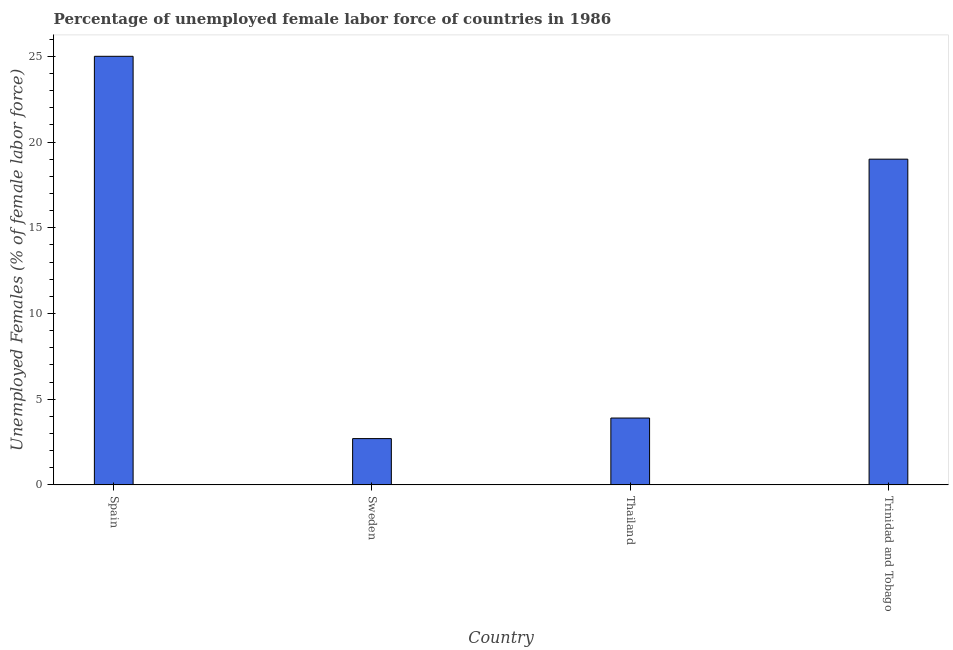What is the title of the graph?
Keep it short and to the point. Percentage of unemployed female labor force of countries in 1986. What is the label or title of the Y-axis?
Provide a succinct answer. Unemployed Females (% of female labor force). What is the total unemployed female labour force in Sweden?
Your answer should be compact. 2.7. Across all countries, what is the maximum total unemployed female labour force?
Give a very brief answer. 25. Across all countries, what is the minimum total unemployed female labour force?
Keep it short and to the point. 2.7. What is the sum of the total unemployed female labour force?
Your answer should be compact. 50.6. What is the difference between the total unemployed female labour force in Spain and Sweden?
Provide a short and direct response. 22.3. What is the average total unemployed female labour force per country?
Offer a very short reply. 12.65. What is the median total unemployed female labour force?
Ensure brevity in your answer.  11.45. What is the ratio of the total unemployed female labour force in Sweden to that in Thailand?
Offer a very short reply. 0.69. Is the total unemployed female labour force in Sweden less than that in Trinidad and Tobago?
Your response must be concise. Yes. Is the difference between the total unemployed female labour force in Spain and Trinidad and Tobago greater than the difference between any two countries?
Make the answer very short. No. What is the difference between the highest and the second highest total unemployed female labour force?
Your response must be concise. 6. What is the difference between the highest and the lowest total unemployed female labour force?
Your answer should be very brief. 22.3. Are all the bars in the graph horizontal?
Your answer should be compact. No. What is the Unemployed Females (% of female labor force) in Sweden?
Offer a very short reply. 2.7. What is the Unemployed Females (% of female labor force) in Thailand?
Give a very brief answer. 3.9. What is the difference between the Unemployed Females (% of female labor force) in Spain and Sweden?
Your answer should be very brief. 22.3. What is the difference between the Unemployed Females (% of female labor force) in Spain and Thailand?
Offer a very short reply. 21.1. What is the difference between the Unemployed Females (% of female labor force) in Spain and Trinidad and Tobago?
Give a very brief answer. 6. What is the difference between the Unemployed Females (% of female labor force) in Sweden and Trinidad and Tobago?
Provide a short and direct response. -16.3. What is the difference between the Unemployed Females (% of female labor force) in Thailand and Trinidad and Tobago?
Provide a short and direct response. -15.1. What is the ratio of the Unemployed Females (% of female labor force) in Spain to that in Sweden?
Your answer should be very brief. 9.26. What is the ratio of the Unemployed Females (% of female labor force) in Spain to that in Thailand?
Keep it short and to the point. 6.41. What is the ratio of the Unemployed Females (% of female labor force) in Spain to that in Trinidad and Tobago?
Give a very brief answer. 1.32. What is the ratio of the Unemployed Females (% of female labor force) in Sweden to that in Thailand?
Ensure brevity in your answer.  0.69. What is the ratio of the Unemployed Females (% of female labor force) in Sweden to that in Trinidad and Tobago?
Ensure brevity in your answer.  0.14. What is the ratio of the Unemployed Females (% of female labor force) in Thailand to that in Trinidad and Tobago?
Keep it short and to the point. 0.2. 